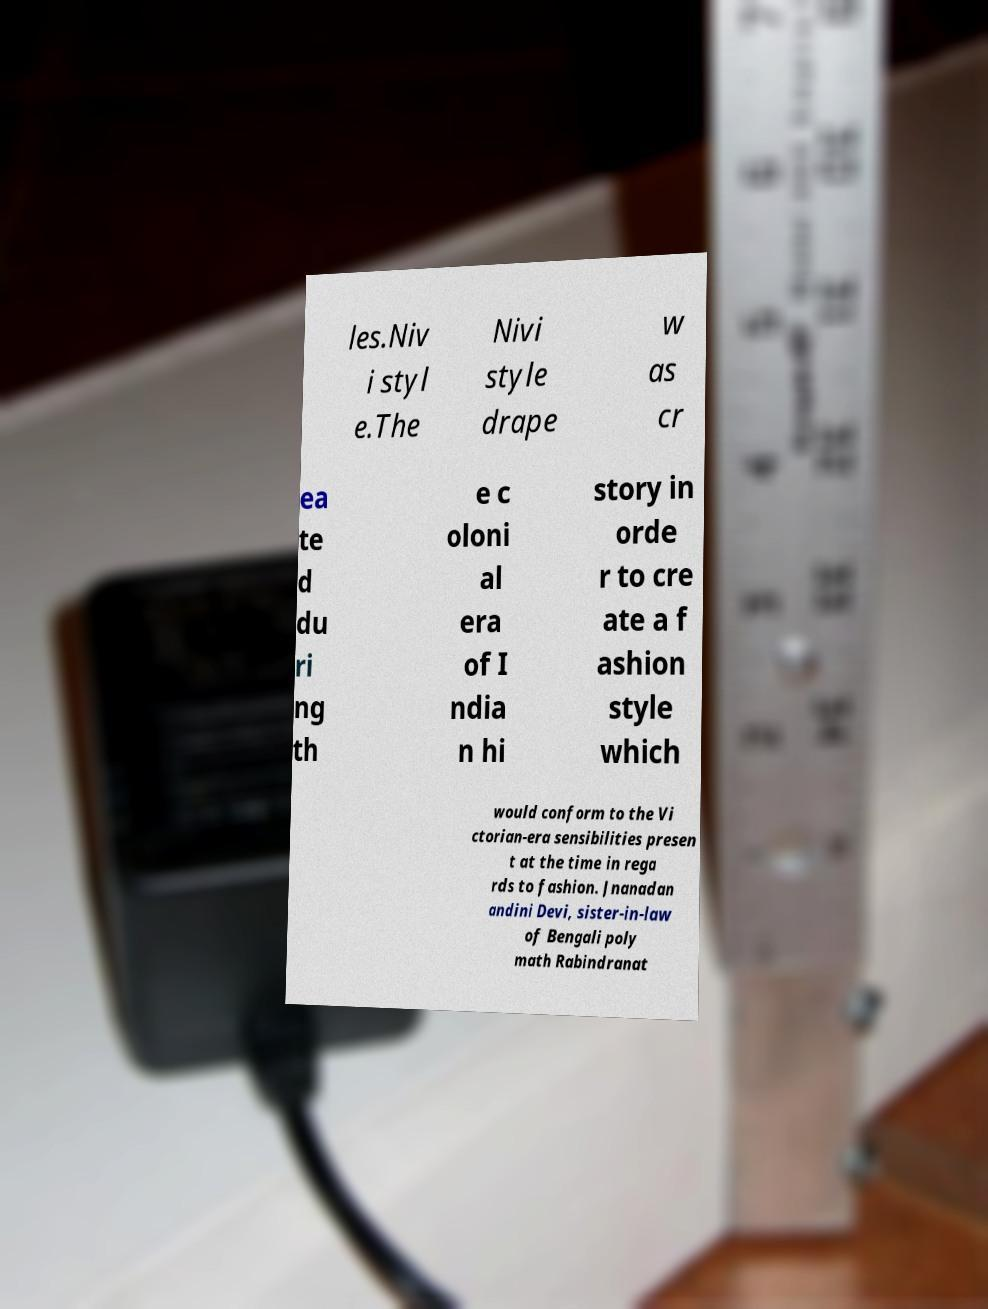Could you assist in decoding the text presented in this image and type it out clearly? les.Niv i styl e.The Nivi style drape w as cr ea te d du ri ng th e c oloni al era of I ndia n hi story in orde r to cre ate a f ashion style which would conform to the Vi ctorian-era sensibilities presen t at the time in rega rds to fashion. Jnanadan andini Devi, sister-in-law of Bengali poly math Rabindranat 